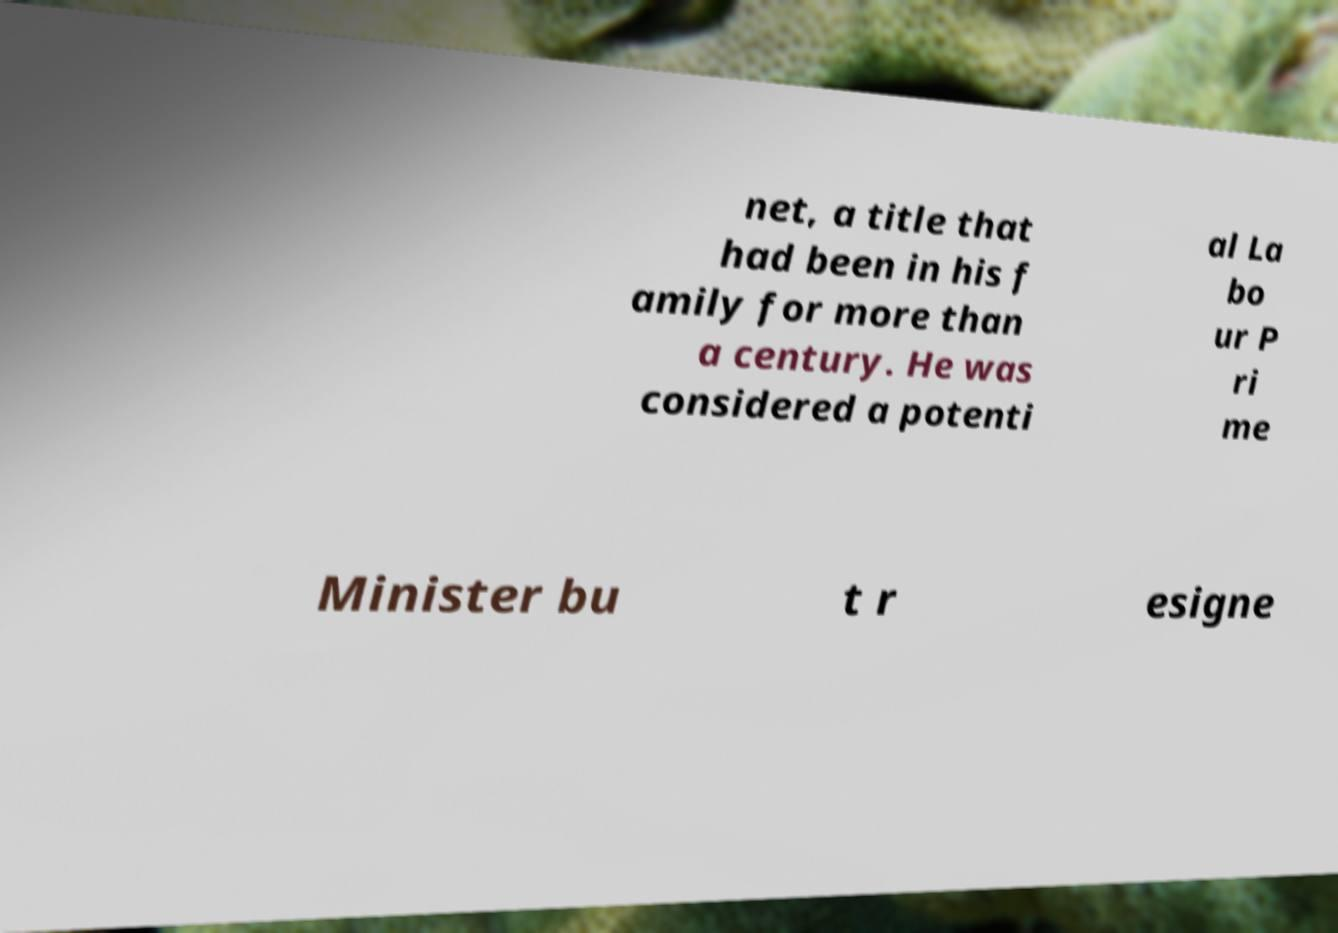Please identify and transcribe the text found in this image. net, a title that had been in his f amily for more than a century. He was considered a potenti al La bo ur P ri me Minister bu t r esigne 